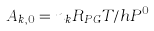Convert formula to latex. <formula><loc_0><loc_0><loc_500><loc_500>A _ { k , 0 } = n _ { k } R _ { P G } T / h P ^ { 0 }</formula> 